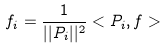<formula> <loc_0><loc_0><loc_500><loc_500>f _ { i } = \frac { 1 } { | | P _ { i } | | ^ { 2 } } < P _ { i } , f ></formula> 